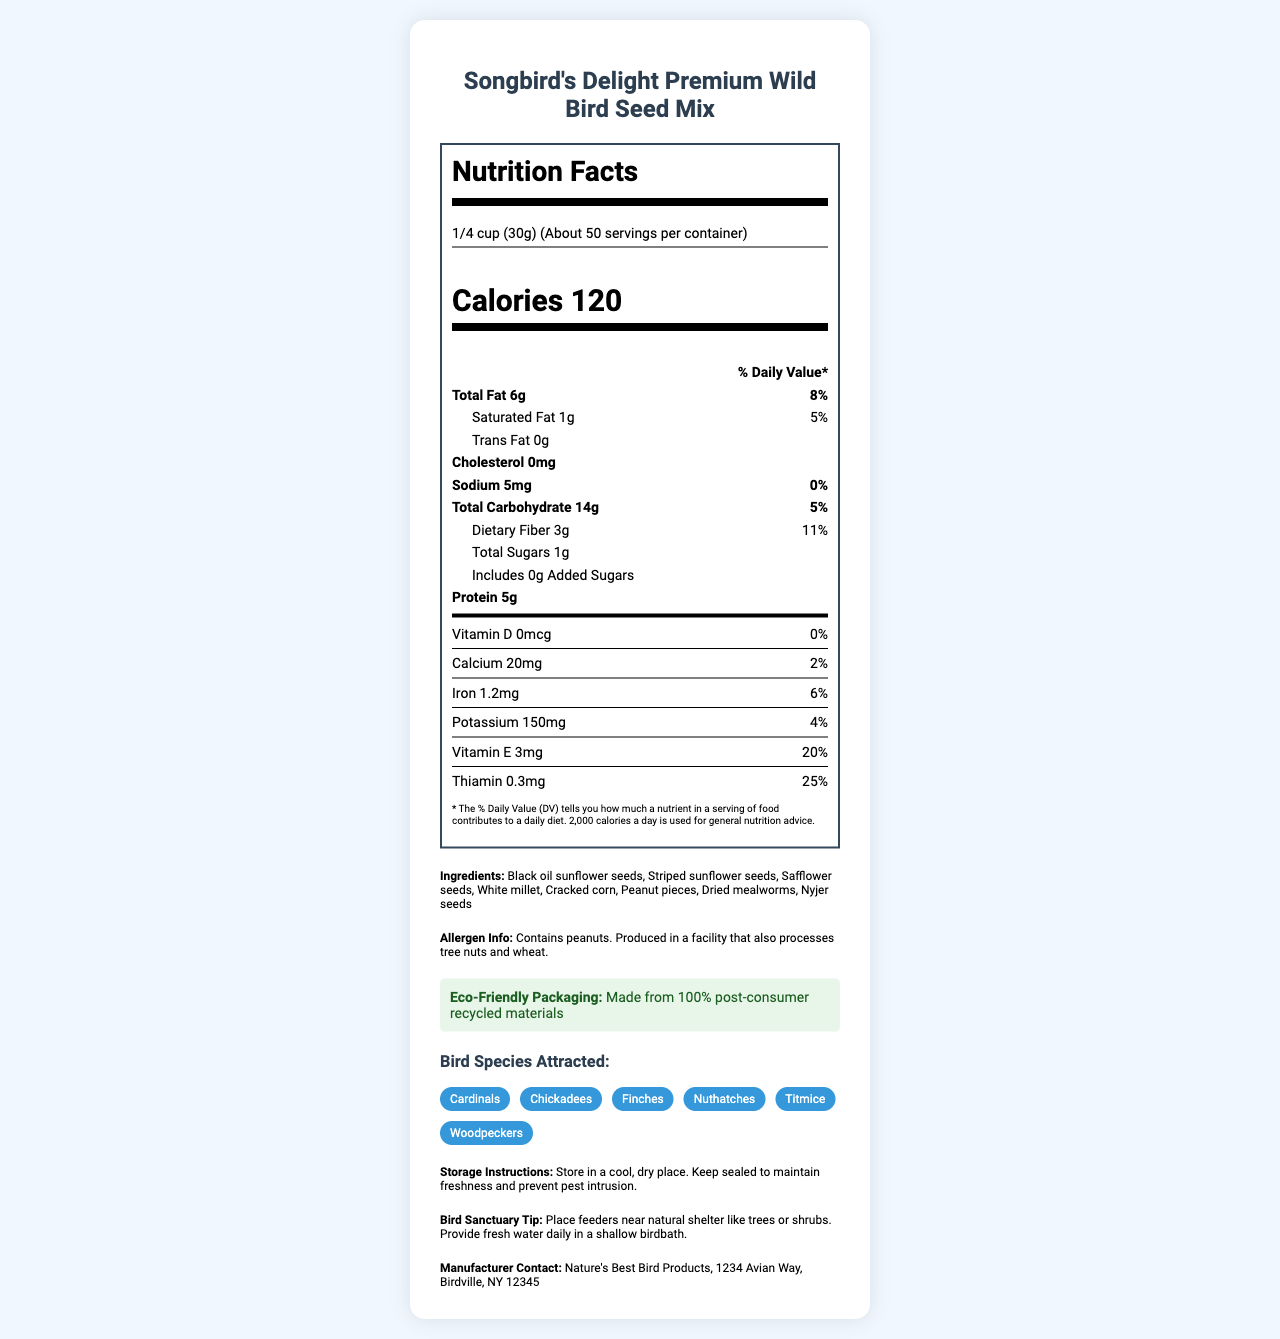what is the product name? The product name is mentioned at the top of the document under the title "Nutrition Facts - Songbird's Delight Premium Wild Bird Seed Mix".
Answer: Songbird's Delight Premium Wild Bird Seed Mix how many servings per container are there? The document states "About 50" servings per container under the serving size information.
Answer: About 50 what is the amount of protein in one serving? The nutrient breakdown shows that each serving contains 5 grams of protein.
Answer: 5g which bird species are attracted to this seed mix? The bird species attracted to this seed mix are listed under the "Bird Species Attracted" section.
Answer: Cardinals, Chickadees, Finches, Nuthatches, Titmice, Woodpeckers how much dietary fiber is in one serving? The dietary fiber content is shown in the nutrient breakdown as 3 grams per serving with a daily value of 11%.
Answer: 3g which of the following is NOT listed as one of the ingredients? A. White millet B. Brown rice C. Cracked corn D. Black oil sunflower seeds The ingredients listed include white millet, cracked corn, and black oil sunflower seeds, but not brown rice.
Answer: B. Brown rice what % daily value of vitamin E is in each serving? A. 10% B. 15% C. 20% D. 25% The document indicates that each serving contains 3mg of Vitamin E, which equals 20% of the daily value.
Answer: C. 20% does the bird seed mix contain any tree nuts? The allergen information states that it contains peanuts and is produced in a facility that processes tree nuts and wheat.
Answer: Yes what instructions are given for storing the bird seed mix? The storage instructions specify to store it in a cool, dry place and to keep it sealed to maintain freshness and prevent pests.
Answer: Store in a cool, dry place. Keep sealed to maintain freshness and prevent pest intrusion. summarize the information provided in the document The document focuses on the nutritional content and variety of seeds in the bird mix, useful instructions for storage and usage, and highlights the eco-friendly aspect and the types of birds it attracts.
Answer: The document presents the nutrition facts for Songbird's Delight Premium Wild Bird Seed Mix. It details the serving size, servings per container, calorie count, and a complete nutrient breakdown including fats, cholesterol, sodium, carbohydrates, and proteins. It also lists the ingredients, allergen information, bird species attracted, storage instructions, eco-friendly packaging, bird sanctuary tips, and manufacturer contact details. is there any information about the amount of Vitamin C in this bird seed mix? The document does not list any information regarding the amount of Vitamin C in this bird seed mix.
Answer: Cannot be determined 